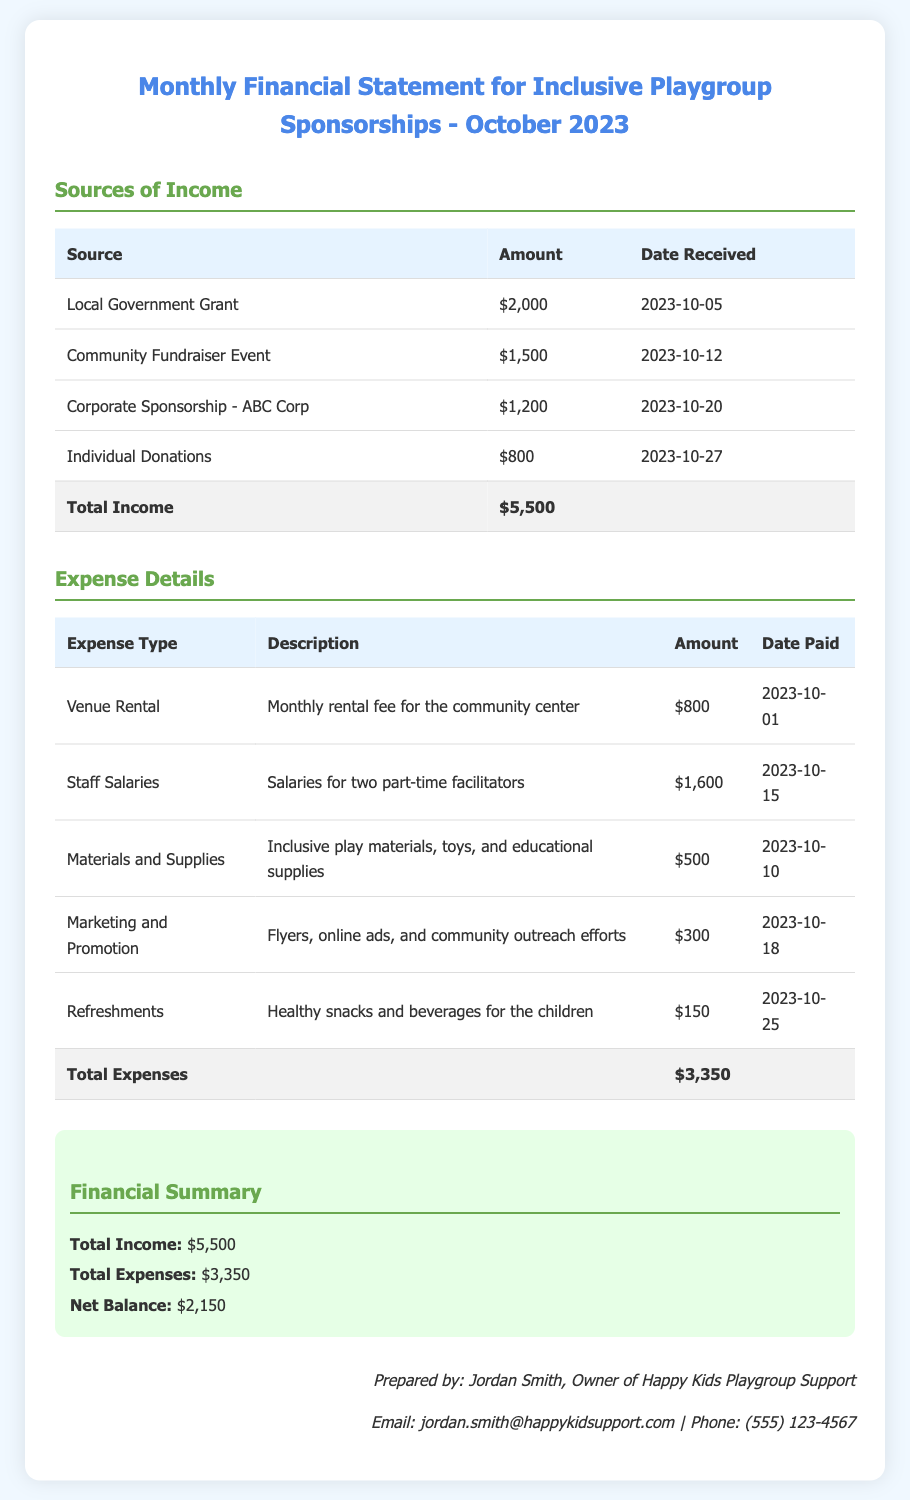what is the total income? The total income is identified at the bottom of the income table, which is the sum of all income sources.
Answer: $5,500 what is the total expense amount? The total expenses are presented at the bottom of the expense table, summarizing all the costs incurred.
Answer: $3,350 who prepared the financial statement? The preparer of the financial statement is stated in the footer section of the document.
Answer: Jordan Smith how much was received from individual donations? The amount from individual donations is specified in the income table.
Answer: $800 what is the net balance calculated as? The net balance is the difference between total income and total expenses, as outlined in the financial summary section.
Answer: $2,150 what type of grant is mentioned as a source of income? The document specifies the type of grant received in the income section.
Answer: Local Government Grant how much was spent on materials and supplies? The detail for materials and supplies is listed under the expense type in the expense table.
Answer: $500 on what date was the community fundraiser event income received? The date of the community fundraiser event income is provided in the income table.
Answer: 2023-10-12 what description is given for the staff salaries expense? The expense type includes a description that clarifies what the staff salaries are for.
Answer: Salaries for two part-time facilitators 